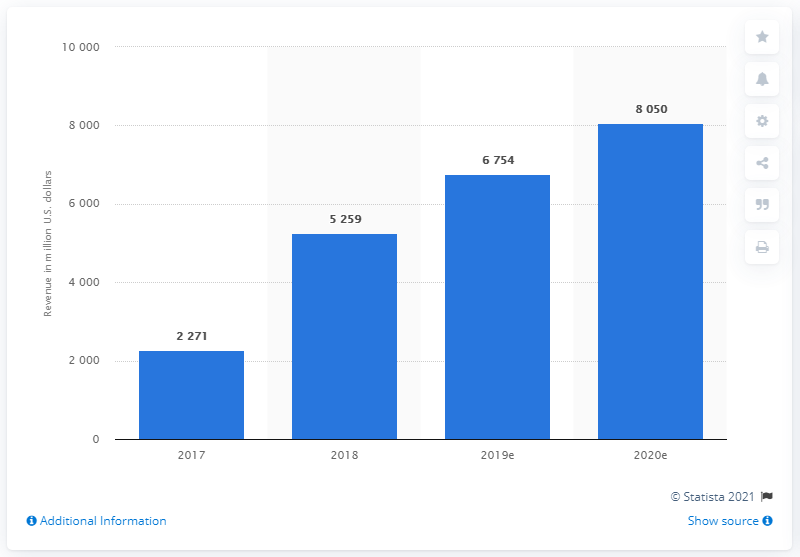Give some essential details in this illustration. In 2018, LinkedIn's revenue was $5259 million. In the fiscal year 2020, LinkedIn's annual revenue was approximately $8050 million. 